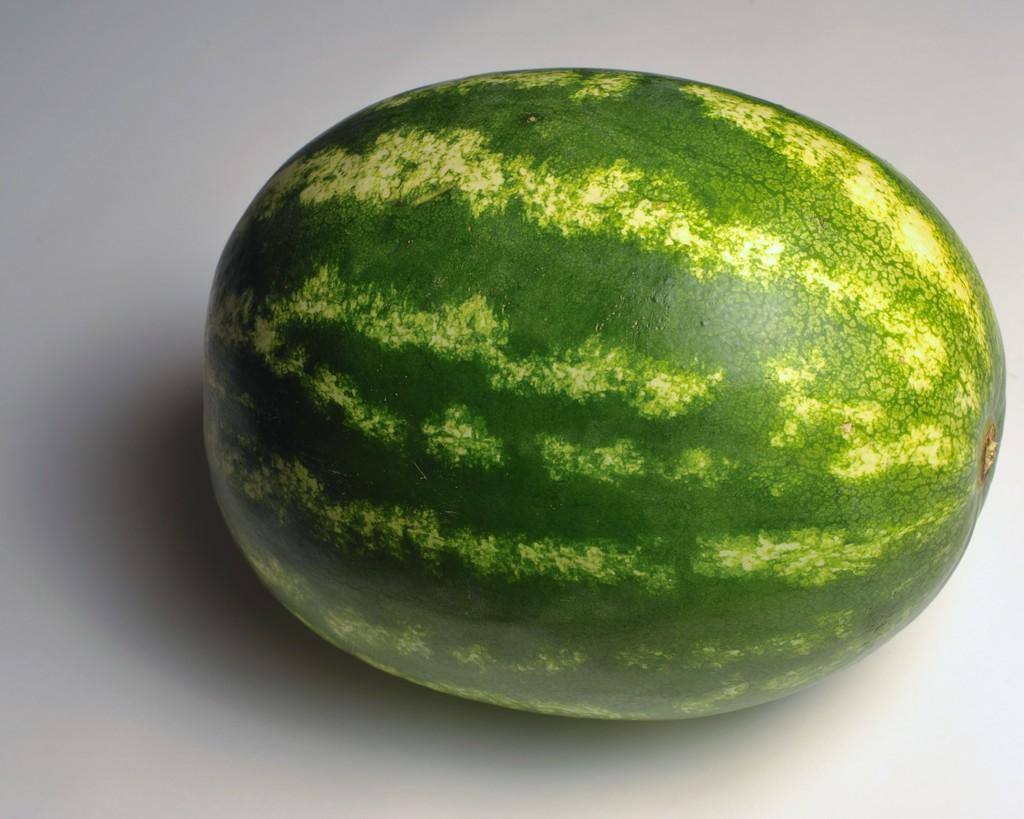What is the main subject of the image? The main subject of the image is a watermelon. Can you describe the color of the watermelon? The watermelon has a green and yellow color. What color is the background of the image? The background of the image is white. How many cows can be seen grazing in the background of the image? There are no cows present in the image; the background is white. What type of zephyr is blowing through the watermelon in the image? There is no zephyr present in the image, as it is a term related to wind and not visible in the image. 